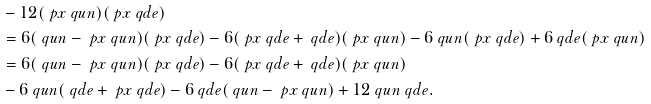Convert formula to latex. <formula><loc_0><loc_0><loc_500><loc_500>& - 1 2 ( \ p x \ q u n ) ( \ p x \ q d e ) \\ & = 6 ( \ q u n - \ p x \ q u n ) ( \ p x \ q d e ) - 6 ( \ p x \ q d e + \ q d e ) ( \ p x \ q u n ) - 6 \ q u n ( \ p x \ q d e ) + 6 \ q d e ( \ p x \ q u n ) \\ & = 6 ( \ q u n - \ p x \ q u n ) ( \ p x \ q d e ) - 6 ( \ p x \ q d e + \ q d e ) ( \ p x \ q u n ) \\ & - 6 \ q u n ( \ q d e + \ p x \ q d e ) - 6 \ q d e ( \ q u n - \ p x \ q u n ) + 1 2 \ q u n \ q d e .</formula> 